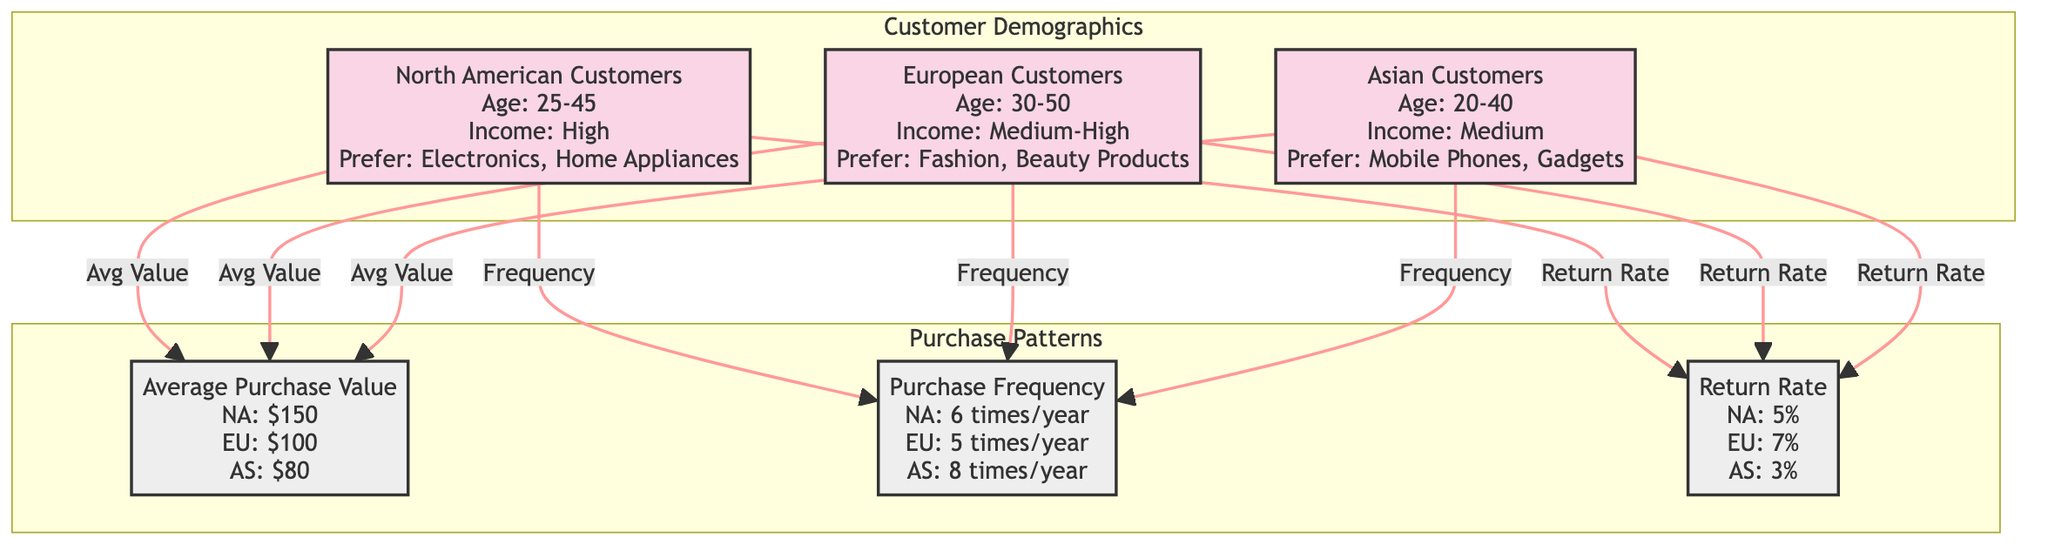What is the average purchase value for North American customers? The diagram shows the average purchase values for different customer demographics. North American customers have an average purchase value of $150, which is directly linked to the corresponding node in the diagram.
Answer: $150 What is the purchase frequency for European customers? The purchase frequency information is outlined in the diagram, specifically for European customers, which is noted as 5 times per year. This value is connected to the European customer node.
Answer: 5 times/year What percentage is the return rate for Asian customers? By referring to the return rate node in the diagram, it indicates that the return rate for Asian customers is 3%. This information is clearly represented in the connections between the Asian customer demographic and the return rate data.
Answer: 3% Which customer demographic prefers fashion and beauty products? The customer preference for fashion and beauty products is specifically linked to European customers in the diagram. This preference is noted clearly within the European customer node.
Answer: European Customers How does the average purchase value of North American customers compare to that of Asian customers? To compare the average purchase values, we look at both nodes: North American customers have an average purchase value of $150, while Asian customers have an average value of $80. The difference here indicates that North American customers spend more on average.
Answer: Higher What is the total number of customer demographics presented in the diagram? The diagram categorizes customers into three distinct demographics: North American, European, and Asian. By counting these categories, we find that there are three customer demographics total.
Answer: 3 What is the highest average purchase value among the customer demographics? Evaluating the average purchase values displayed in the diagram: North American customers have $150, European customers have $100, and Asian customers have $80. Thus, North American customers represent the highest average purchase value among the groups.
Answer: $150 Which demographic has the highest purchase frequency? Looking at the purchase frequency for each demographic shown in the diagram, North American customers make purchases 6 times a year, while Asian customers make purchases 8 times. Thus, Asian customers have the highest frequency of purchases.
Answer: Asian Customers What type of products do Asian customers prefer? The diagram specifically notes that Asian customers prefer mobile phones and gadgets, which is clearly indicated in the Asian customer node.
Answer: Mobile Phones, Gadgets 